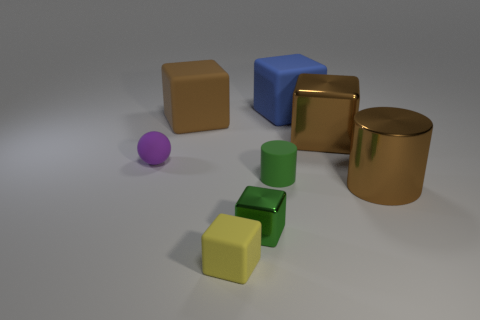There is a tiny object that is in front of the green cube; does it have the same color as the metal cube on the right side of the tiny metal thing?
Your response must be concise. No. What number of small yellow rubber cubes are right of the yellow cube?
Keep it short and to the point. 0. How many metal cubes have the same color as the rubber cylinder?
Give a very brief answer. 1. Do the small green thing in front of the green cylinder and the yellow object have the same material?
Offer a terse response. No. What number of small purple objects have the same material as the brown cylinder?
Provide a short and direct response. 0. Are there more large rubber blocks that are on the right side of the green metal block than brown metallic blocks?
Offer a terse response. No. The cylinder that is the same color as the big metal block is what size?
Give a very brief answer. Large. Is there a big yellow rubber object of the same shape as the large brown matte object?
Provide a short and direct response. No. What number of objects are either balls or small things?
Your answer should be very brief. 4. There is a tiny thing that is left of the small yellow matte thing that is in front of the matte cylinder; how many large blocks are in front of it?
Offer a terse response. 0. 